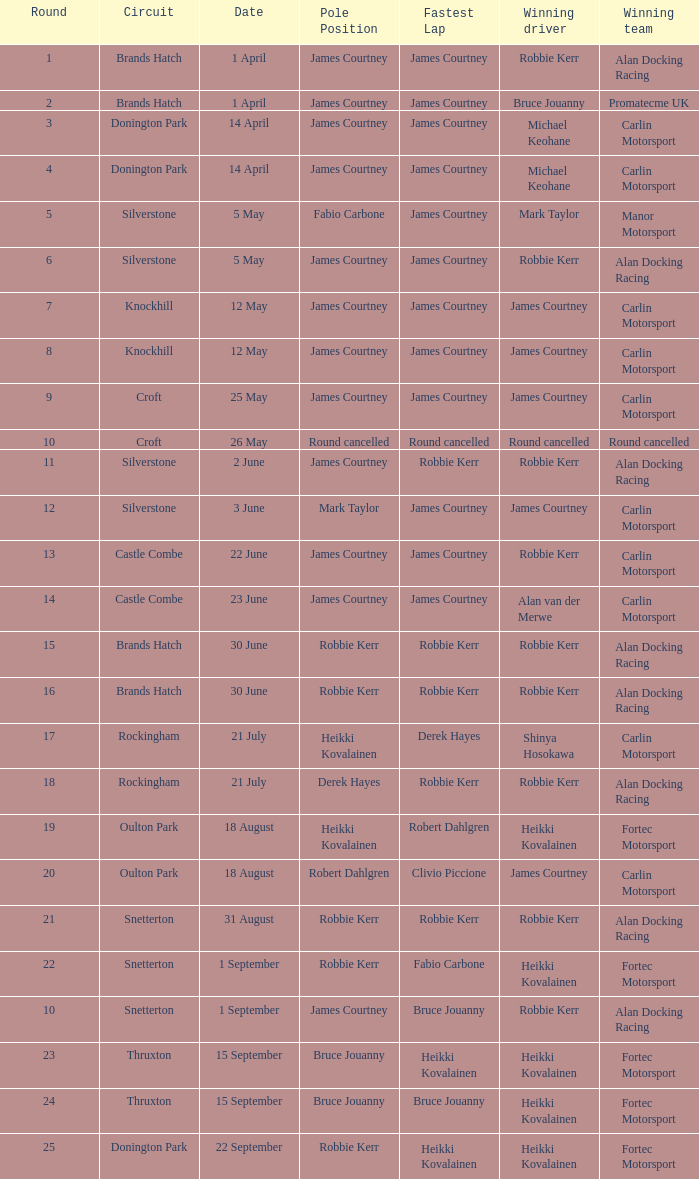How many pole positions for round 20? 1.0. 